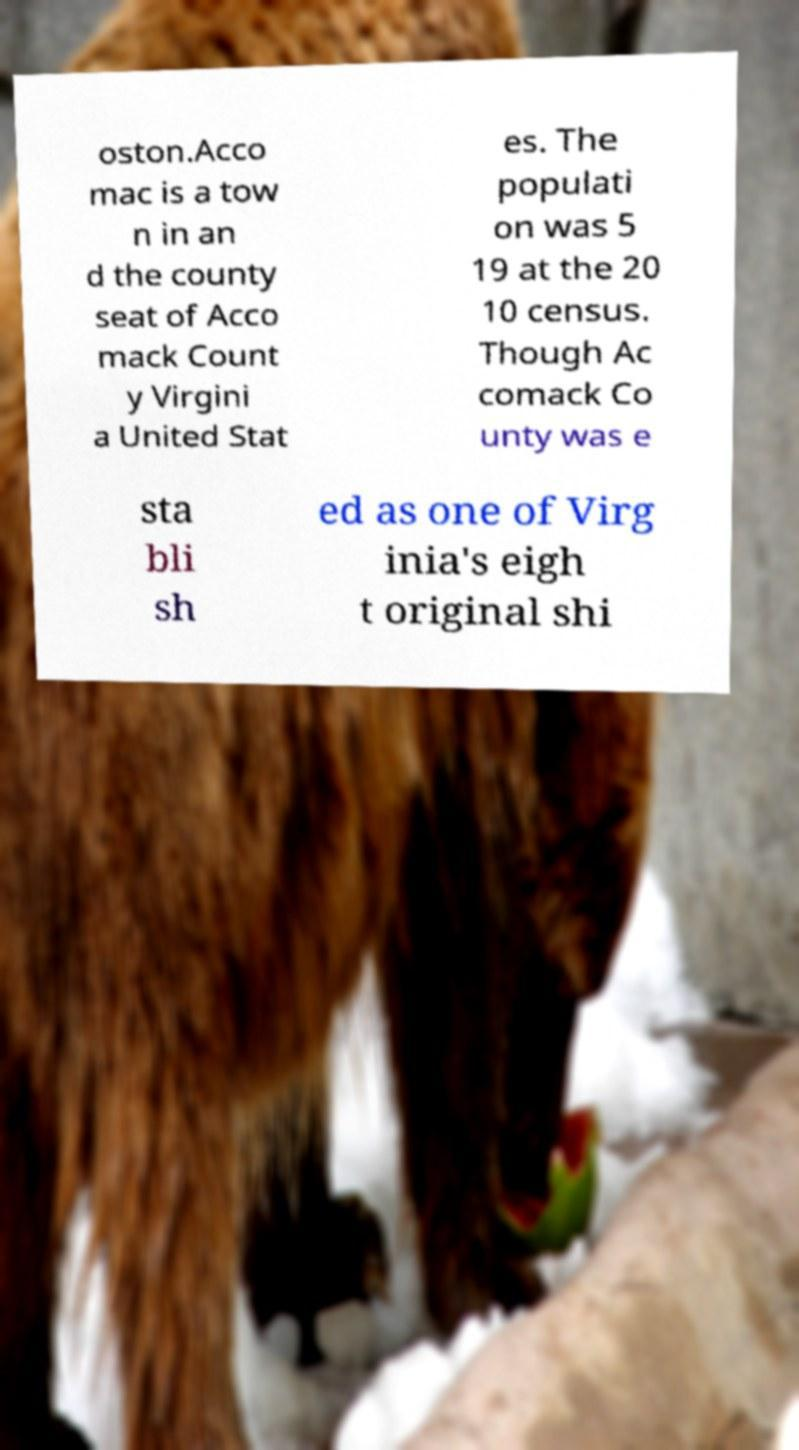What messages or text are displayed in this image? I need them in a readable, typed format. oston.Acco mac is a tow n in an d the county seat of Acco mack Count y Virgini a United Stat es. The populati on was 5 19 at the 20 10 census. Though Ac comack Co unty was e sta bli sh ed as one of Virg inia's eigh t original shi 